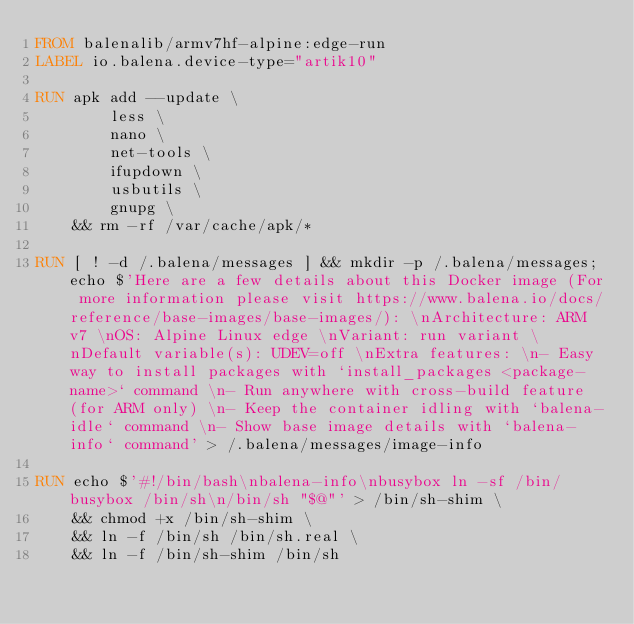Convert code to text. <code><loc_0><loc_0><loc_500><loc_500><_Dockerfile_>FROM balenalib/armv7hf-alpine:edge-run
LABEL io.balena.device-type="artik10"

RUN apk add --update \
		less \
		nano \
		net-tools \
		ifupdown \
		usbutils \
		gnupg \
	&& rm -rf /var/cache/apk/*

RUN [ ! -d /.balena/messages ] && mkdir -p /.balena/messages; echo $'Here are a few details about this Docker image (For more information please visit https://www.balena.io/docs/reference/base-images/base-images/): \nArchitecture: ARM v7 \nOS: Alpine Linux edge \nVariant: run variant \nDefault variable(s): UDEV=off \nExtra features: \n- Easy way to install packages with `install_packages <package-name>` command \n- Run anywhere with cross-build feature  (for ARM only) \n- Keep the container idling with `balena-idle` command \n- Show base image details with `balena-info` command' > /.balena/messages/image-info

RUN echo $'#!/bin/bash\nbalena-info\nbusybox ln -sf /bin/busybox /bin/sh\n/bin/sh "$@"' > /bin/sh-shim \
	&& chmod +x /bin/sh-shim \
	&& ln -f /bin/sh /bin/sh.real \
	&& ln -f /bin/sh-shim /bin/sh</code> 